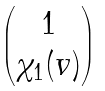<formula> <loc_0><loc_0><loc_500><loc_500>\begin{pmatrix} 1 \\ \chi _ { 1 } ( v ) \end{pmatrix}</formula> 